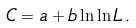<formula> <loc_0><loc_0><loc_500><loc_500>C = a + b \ln \ln L \, .</formula> 